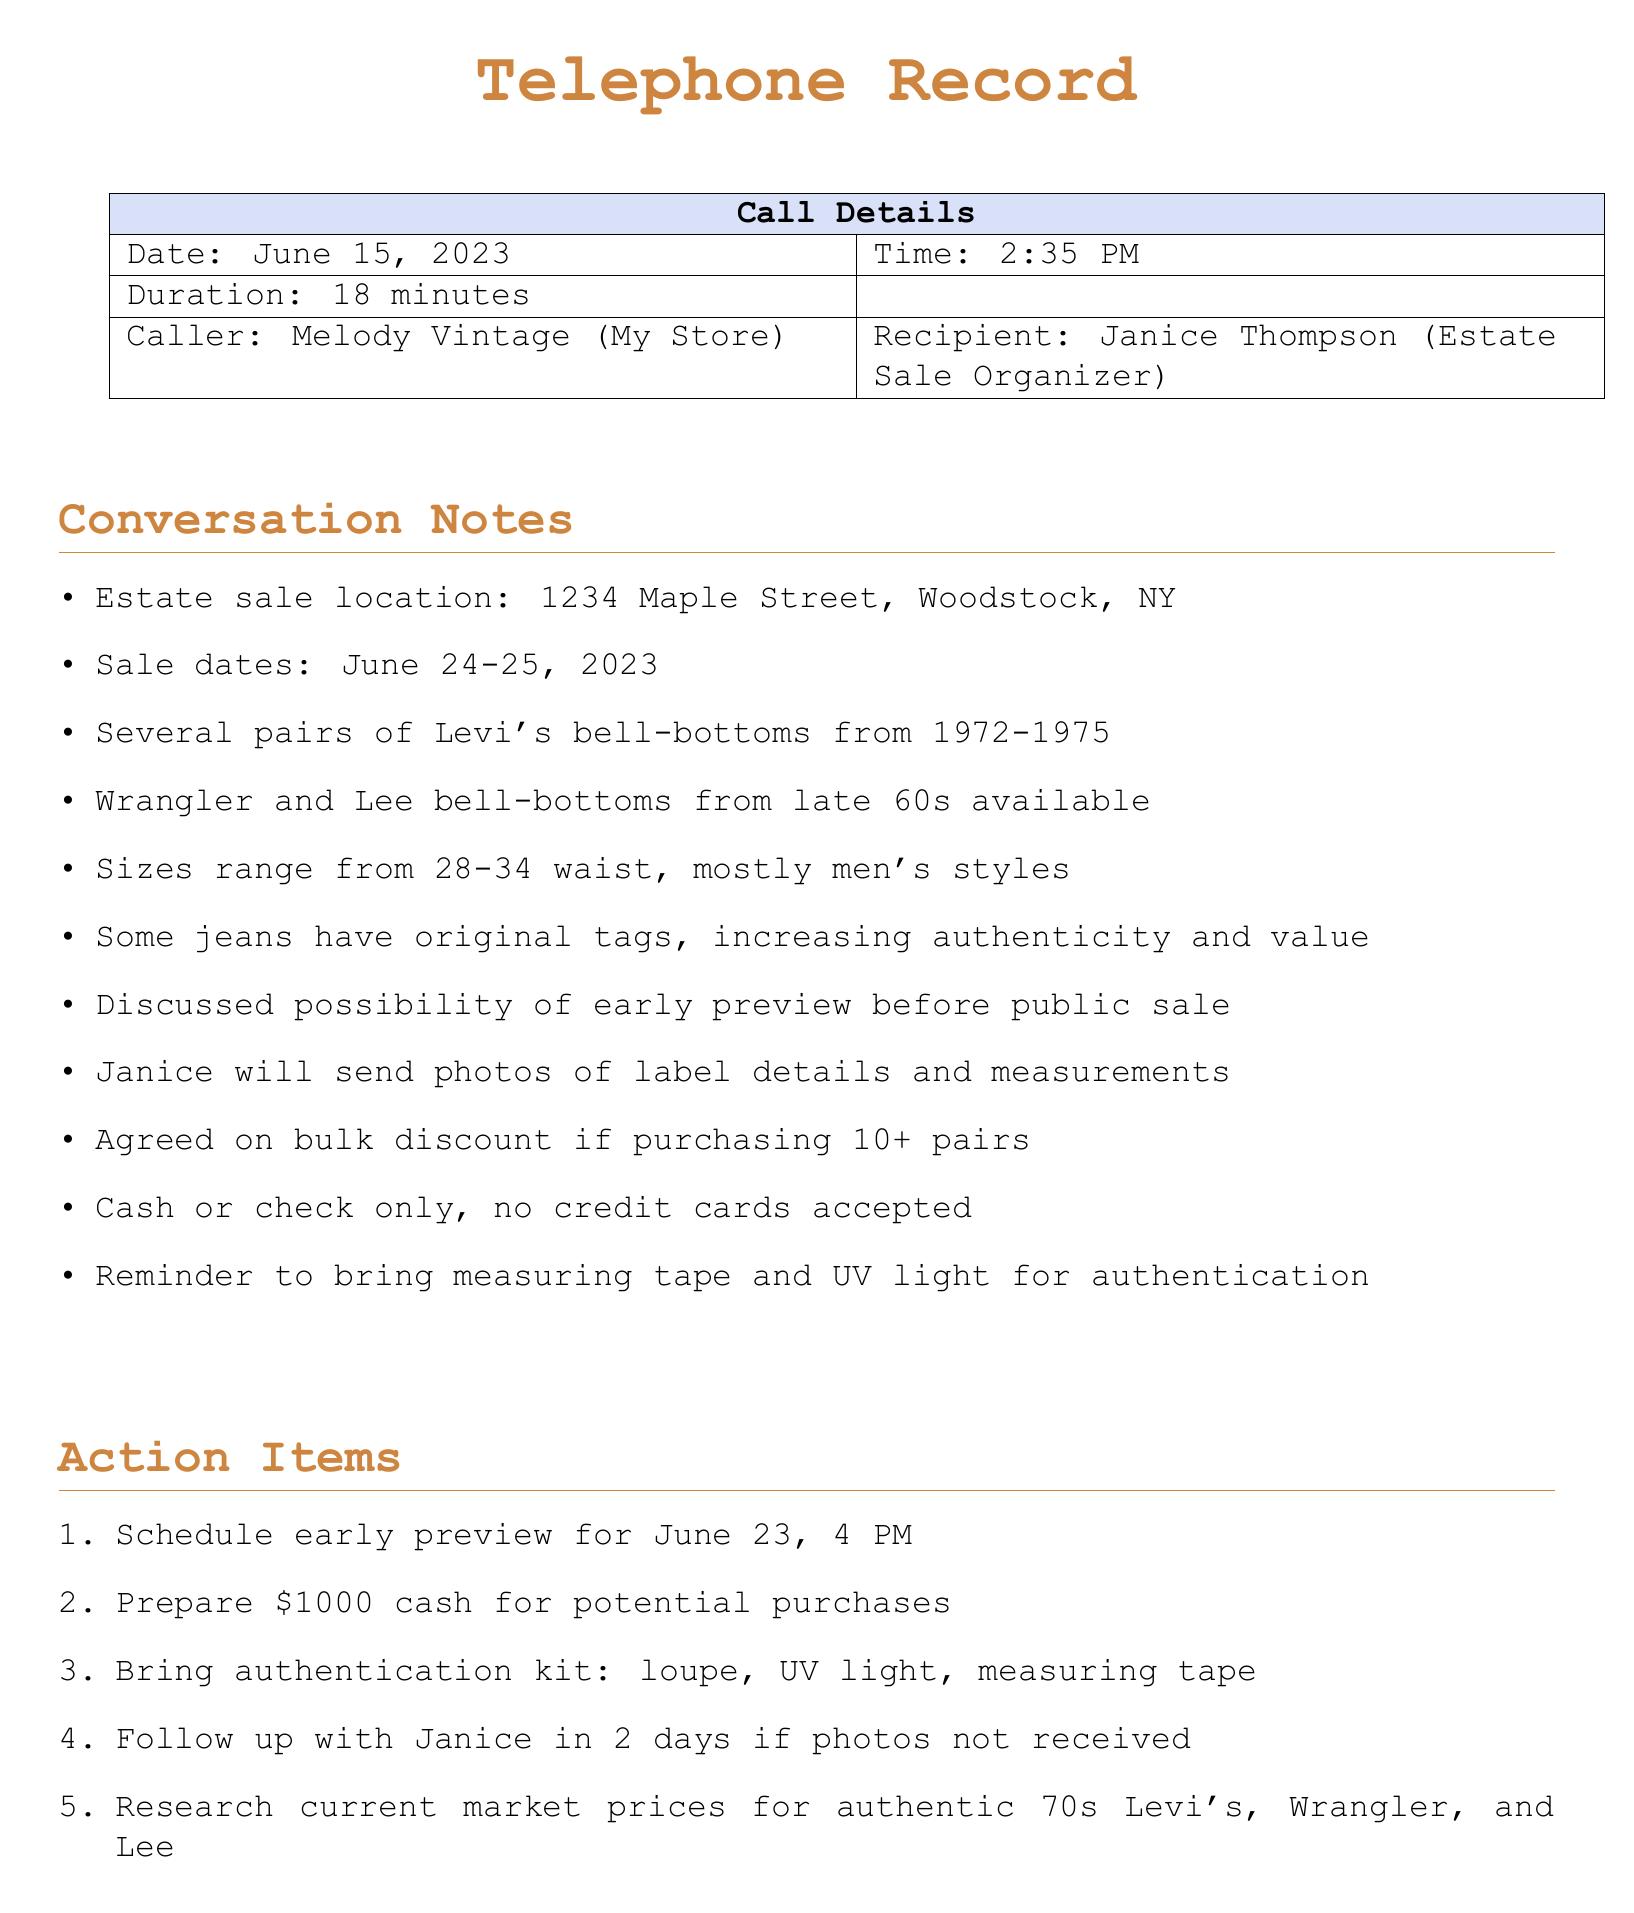what is the date of the estate sale? The date of the estate sale is specified in the conversation notes section.
Answer: June 24-25, 2023 who is the recipient of the call? The recipient of the call is mentioned in the call details section.
Answer: Janice Thompson how long was the call? The duration of the call is provided in the call details section.
Answer: 18 minutes what is the size range of the jeans available? The size range for the jeans is mentioned in the conversation notes.
Answer: 28-34 waist how many pairs of jeans did they discuss getting a bulk discount on? The specific number of jeans required for a bulk discount is given in the conversation notes.
Answer: 10+ what payment methods are accepted at the estate sale? The accepted payment methods are listed in the conversation notes.
Answer: Cash or check only what should be brought for authentication purposes? The necessary items for authentication are listed in the action items.
Answer: Loupe, UV light, measuring tape who will send photos of the jeans? The person responsible for sending photos is mentioned in the conversation notes.
Answer: Janice when is the scheduled early preview? The early preview date and time are mentioned in the action items.
Answer: June 23, 4 PM 